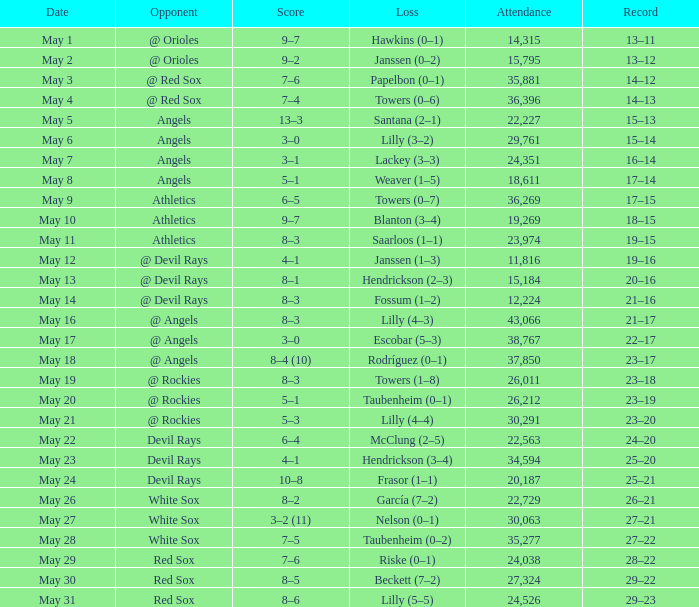What was the average attendance for games with a loss of papelbon (0–1)? 35881.0. 